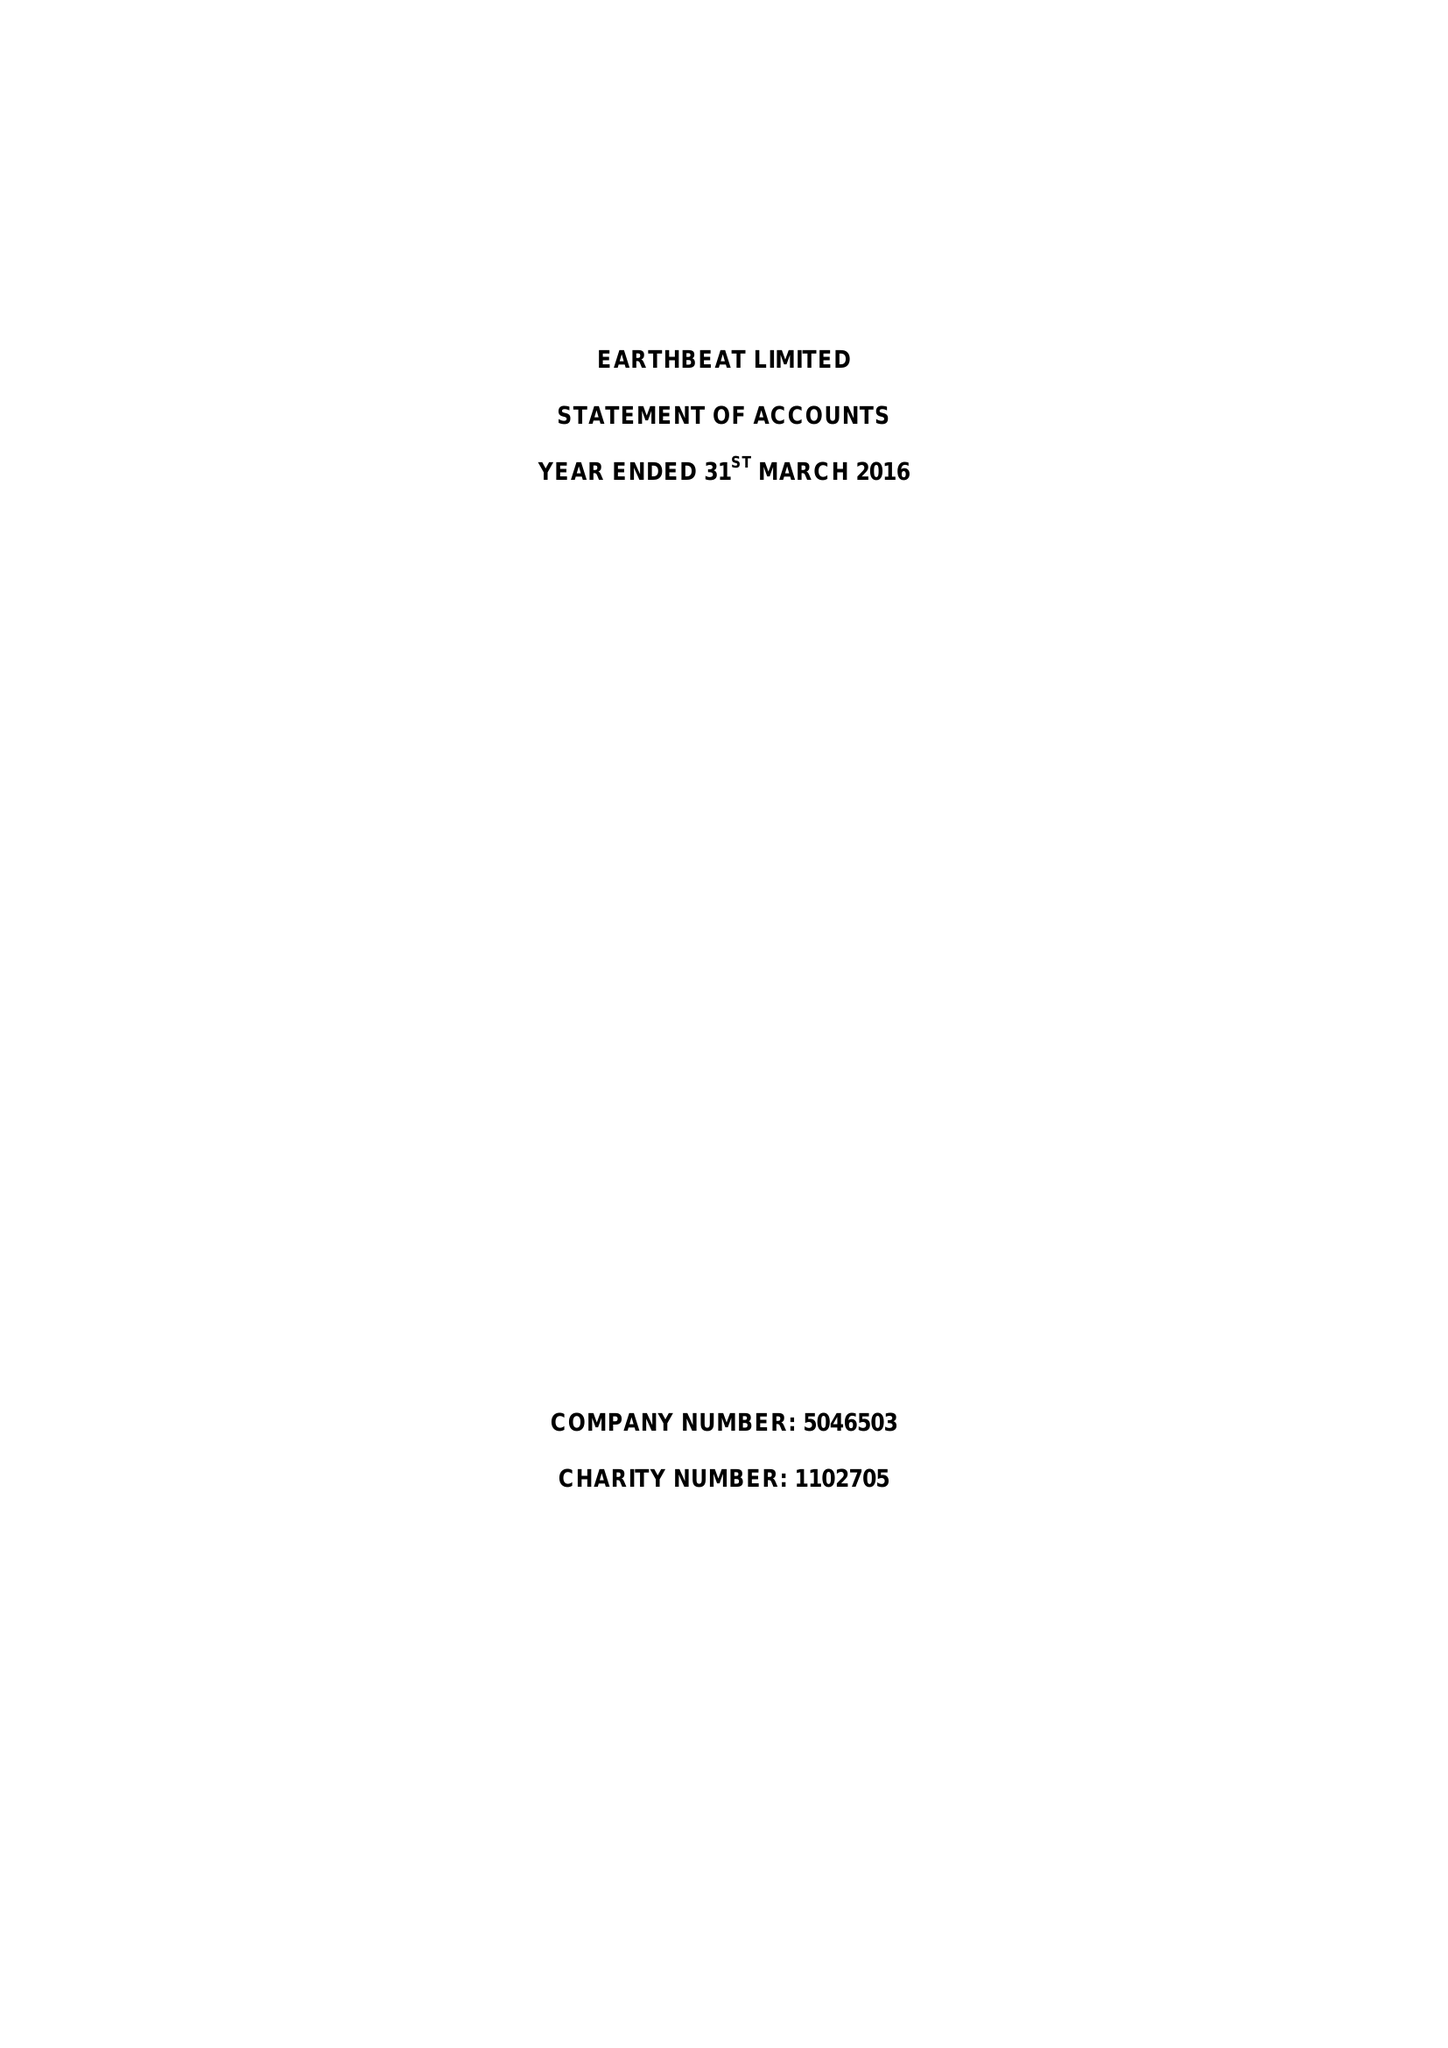What is the value for the address__post_town?
Answer the question using a single word or phrase. REDCAR 